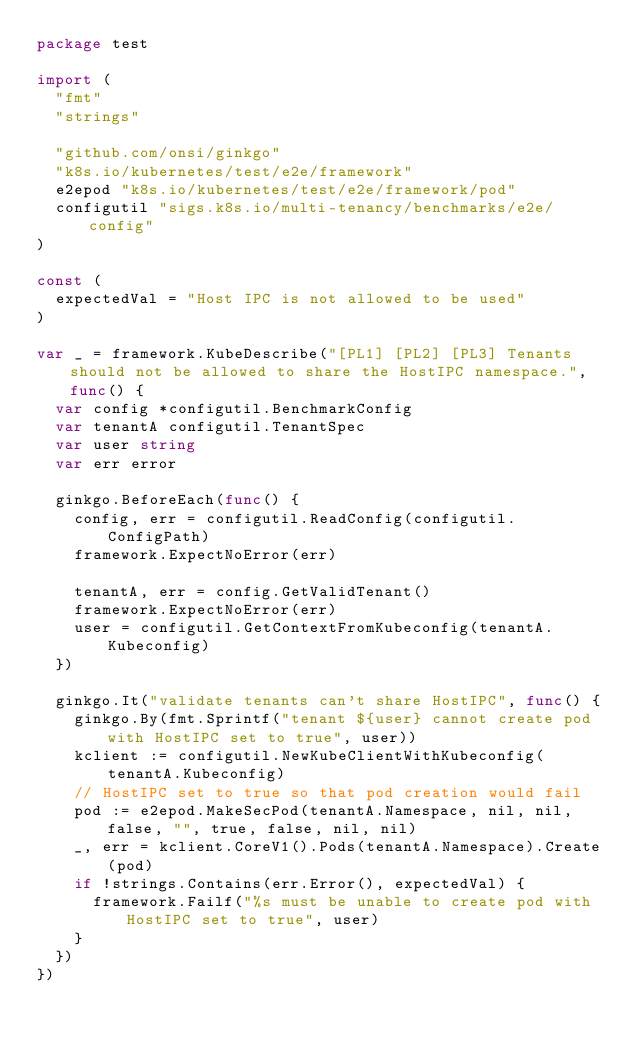<code> <loc_0><loc_0><loc_500><loc_500><_Go_>package test

import (
	"fmt"
	"strings"

	"github.com/onsi/ginkgo"
	"k8s.io/kubernetes/test/e2e/framework"
	e2epod "k8s.io/kubernetes/test/e2e/framework/pod"
	configutil "sigs.k8s.io/multi-tenancy/benchmarks/e2e/config"
)

const (
	expectedVal = "Host IPC is not allowed to be used"
)

var _ = framework.KubeDescribe("[PL1] [PL2] [PL3] Tenants should not be allowed to share the HostIPC namespace.", func() {
	var config *configutil.BenchmarkConfig
	var tenantA configutil.TenantSpec
	var user string
	var err error

	ginkgo.BeforeEach(func() {
		config, err = configutil.ReadConfig(configutil.ConfigPath)
		framework.ExpectNoError(err)

		tenantA, err = config.GetValidTenant()
		framework.ExpectNoError(err)
		user = configutil.GetContextFromKubeconfig(tenantA.Kubeconfig)
	})

	ginkgo.It("validate tenants can't share HostIPC", func() {
		ginkgo.By(fmt.Sprintf("tenant ${user} cannot create pod with HostIPC set to true", user))
		kclient := configutil.NewKubeClientWithKubeconfig(tenantA.Kubeconfig)
		// HostIPC set to true so that pod creation would fail
		pod := e2epod.MakeSecPod(tenantA.Namespace, nil, nil, false, "", true, false, nil, nil)
		_, err = kclient.CoreV1().Pods(tenantA.Namespace).Create(pod)
		if !strings.Contains(err.Error(), expectedVal) {
			framework.Failf("%s must be unable to create pod with HostIPC set to true", user)
		}
	})
})
</code> 